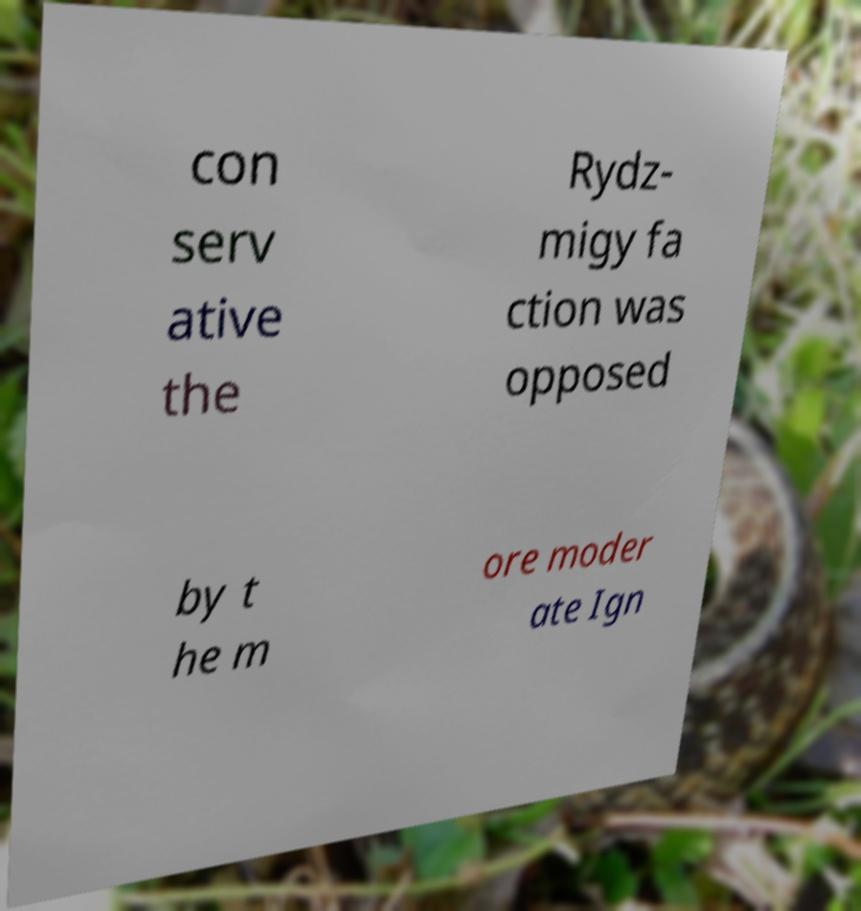Can you accurately transcribe the text from the provided image for me? con serv ative the Rydz- migy fa ction was opposed by t he m ore moder ate Ign 